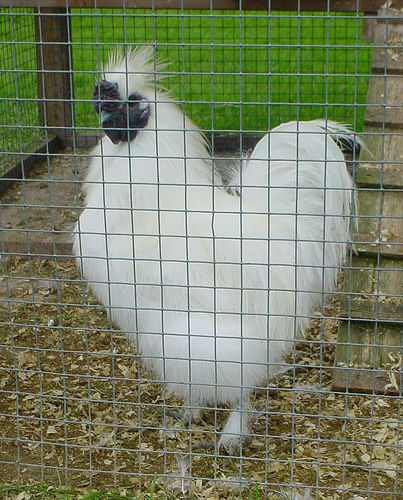<image>
Can you confirm if the chicken is next to the ramp? Yes. The chicken is positioned adjacent to the ramp, located nearby in the same general area. 